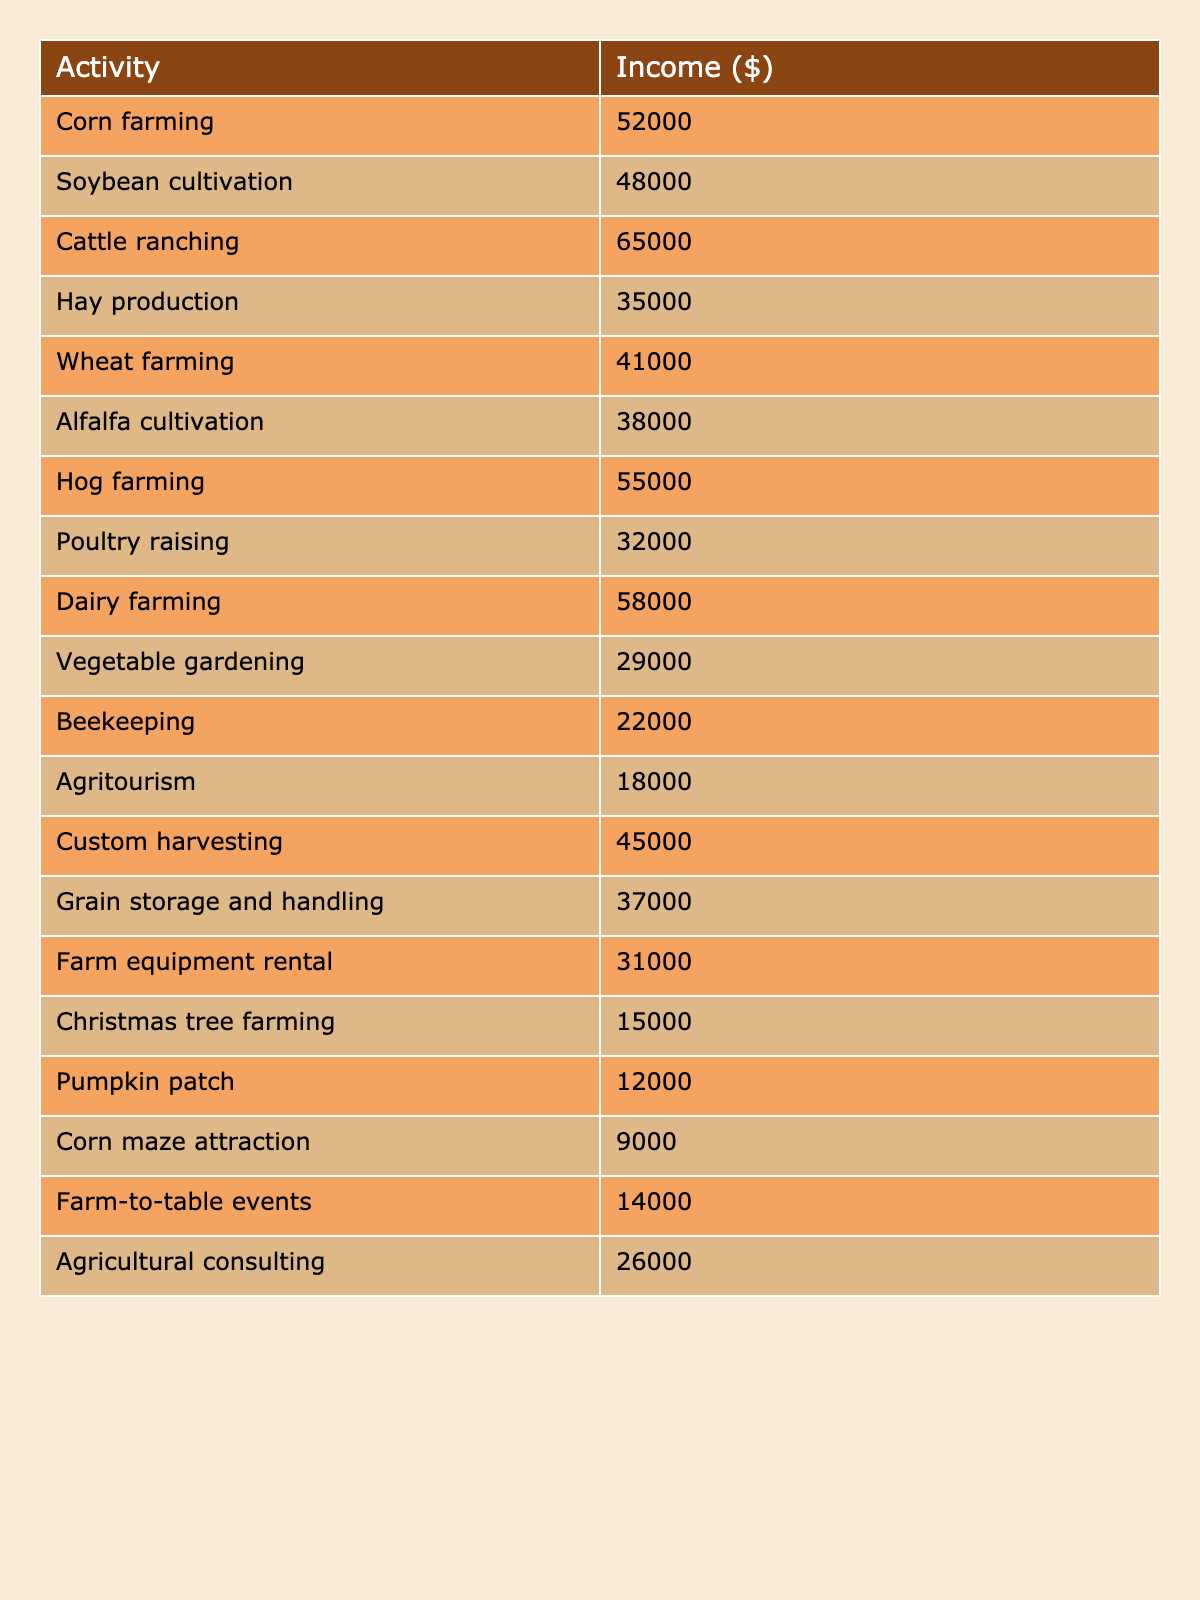What is the income from cattle ranching? The table shows that the income from cattle ranching is listed as $65,000.
Answer: $65,000 What agricultural activity has the highest income? Looking through the table, cattle ranching shows the highest income at $65,000 compared to other activities listed.
Answer: Cattle ranching What is the total income from corn farming and soybean cultivation? The income from corn farming is $52,000 and from soybean cultivation is $48,000. Adding these together gives $52,000 + $48,000 = $100,000.
Answer: $100,000 Is the income from poultry raising higher than that from beekeeping? The table indicates that poultry raising has an income of $32,000, and beekeeping has an income of $22,000. Since $32,000 is greater than $22,000, the statement is true.
Answer: Yes What is the average income across all activities listed? To find the average, we sum all the incomes: $52,000 + $48,000 + $65,000 + $35,000 + $41,000 + $38,000 + $55,000 + $32,000 + $58,000 + $29,000 + $22,000 + $18,000 + $45,000 + $37,000 + $31,000 + $15,000 + $12,000 + $9,000 + $14,000 + $26,000 = $674,000. There are 20 activities, so the average is $674,000 / 20 = $33,700.
Answer: $33,700 What percentage of the total income does the hog farming generate? The income from hog farming is $55,000. First, we calculate the total income of $674,000. Now, to find the percentage: ($55,000 / $674,000) * 100 = approximately 8.15%.
Answer: Approximately 8.15% Which agricultural activity has the lowest income? Reviewing the table, pumpkin patch has the lowest income listed at $12,000 compared to other activities.
Answer: Pumpkin patch How much more income does dairy farming generate than vegetable gardening? Dairy farming has an income of $58,000 and vegetable gardening has $29,000. The difference is calculated as $58,000 - $29,000 = $29,000.
Answer: $29,000 Is the total income from grain storage and handling and farm equipment rental greater than that from tomato gardening and agritourism combined? Grain storage and handling makes $37,000, and farm equipment rental makes $31,000, giving a combined income of $37,000 + $31,000 = $68,000. Tomato gardening (not listed but inferred as vegetable gardening) and agritourism (which is $18,000) would be $29,000 + $18,000 = $47,000. Since $68,000 is greater than $47,000, the statement is true.
Answer: Yes What income activities are below $30,000? The table indicates activities below $30,000: vegetable gardening at $29,000, beekeeping at $22,000, agritourism at $18,000, Christmas tree farming at $15,000, pumpkin patch at $12,000, and corn maze attraction at $9,000.
Answer: Vegetable gardening, beekeeping, agritourism, Christmas tree farming, pumpkin patch, corn maze attraction 